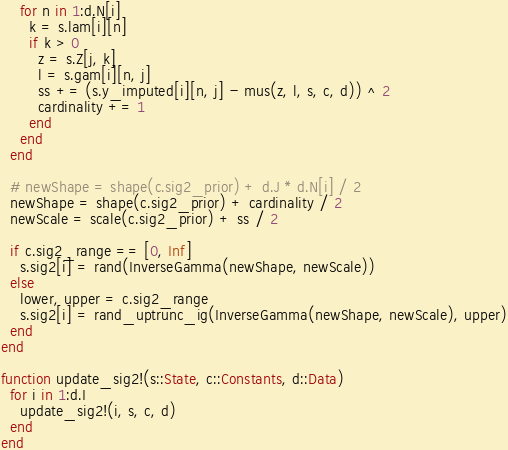<code> <loc_0><loc_0><loc_500><loc_500><_Julia_>    for n in 1:d.N[i]
      k = s.lam[i][n]
      if k > 0
        z = s.Z[j, k]
        l = s.gam[i][n, j]
        ss += (s.y_imputed[i][n, j] - mus(z, l, s, c, d)) ^ 2
        cardinality += 1
      end
    end
  end

  # newShape = shape(c.sig2_prior) + d.J * d.N[i] / 2
  newShape = shape(c.sig2_prior) + cardinality / 2
  newScale = scale(c.sig2_prior) + ss / 2

  if c.sig2_range == [0, Inf]
    s.sig2[i] = rand(InverseGamma(newShape, newScale))
  else
    lower, upper = c.sig2_range
    s.sig2[i] = rand_uptrunc_ig(InverseGamma(newShape, newScale), upper)
  end
end

function update_sig2!(s::State, c::Constants, d::Data)
  for i in 1:d.I
    update_sig2!(i, s, c, d)
  end
end
</code> 